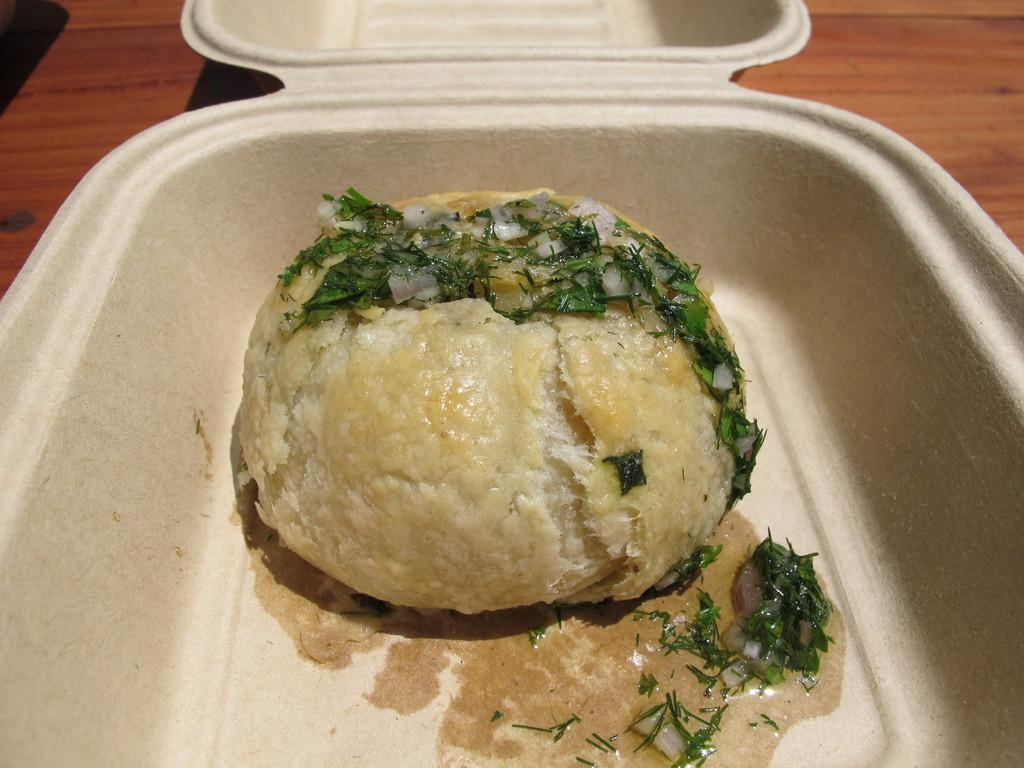What type of food is present in the image? There is a soup in the image. What ingredients can be found in the soup? The soup contains leaf pieces and onion pieces. What is the soup poured on in the image? The soup is poured on a food item. What is the color of the box containing the food item? The box is white-colored. Is the box opened or closed in the image? The box is opened. What type of table is the box placed on? The box is on a wooden table. How many pigs are visible in the image? There are no pigs present in the image. Does the soup cause anyone to sneeze in the image? There is no indication of anyone sneezing in the image. 